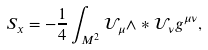Convert formula to latex. <formula><loc_0><loc_0><loc_500><loc_500>S _ { x } = - \frac { 1 } { 4 } \int _ { M ^ { 2 } } \mathcal { U } _ { \mu } \wedge \ast \mathcal { U } _ { \nu } g ^ { \mu \nu } ,</formula> 